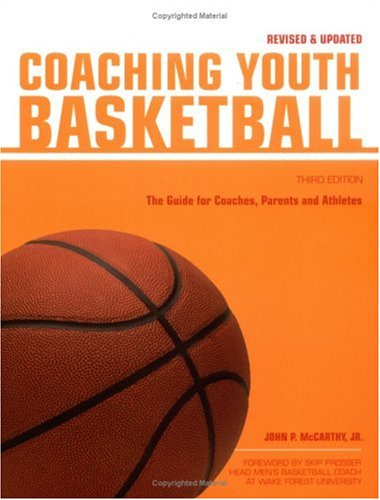What skills and strategies does this book teach about coaching youth basketball? This book covers a range of topics crucial for coaching youth basketball, including fundamental skills, team building exercises, and motivational techniques to support young athletes in their development. 